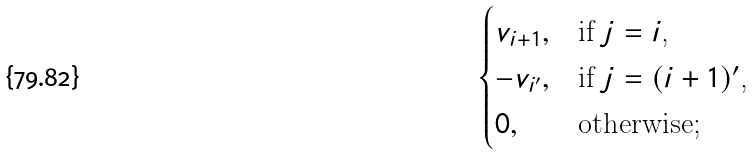Convert formula to latex. <formula><loc_0><loc_0><loc_500><loc_500>\begin{cases} { v } _ { i + 1 } , & \text {if $j=i$,} \\ - { v } _ { i ^ { \prime } } , & \text {if $j=(i+1)^{\prime}$,} \\ 0 , & \text {otherwise;} \end{cases}</formula> 